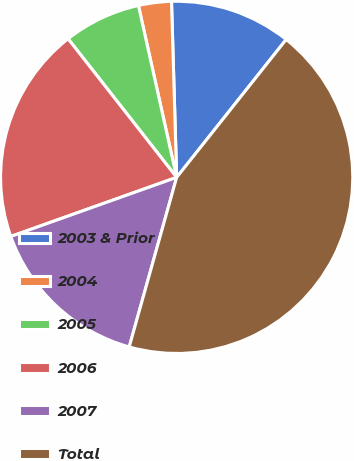Convert chart. <chart><loc_0><loc_0><loc_500><loc_500><pie_chart><fcel>2003 & Prior<fcel>2004<fcel>2005<fcel>2006<fcel>2007<fcel>Total<nl><fcel>11.15%<fcel>3.02%<fcel>7.09%<fcel>19.87%<fcel>15.21%<fcel>43.66%<nl></chart> 